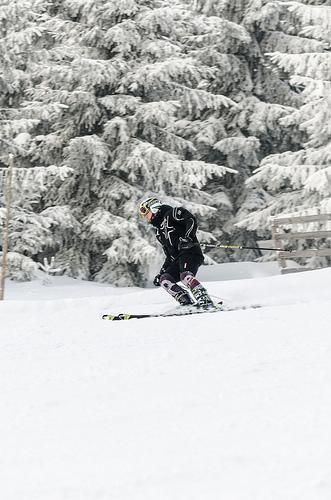How many boots is the person wearing?
Give a very brief answer. 2. 